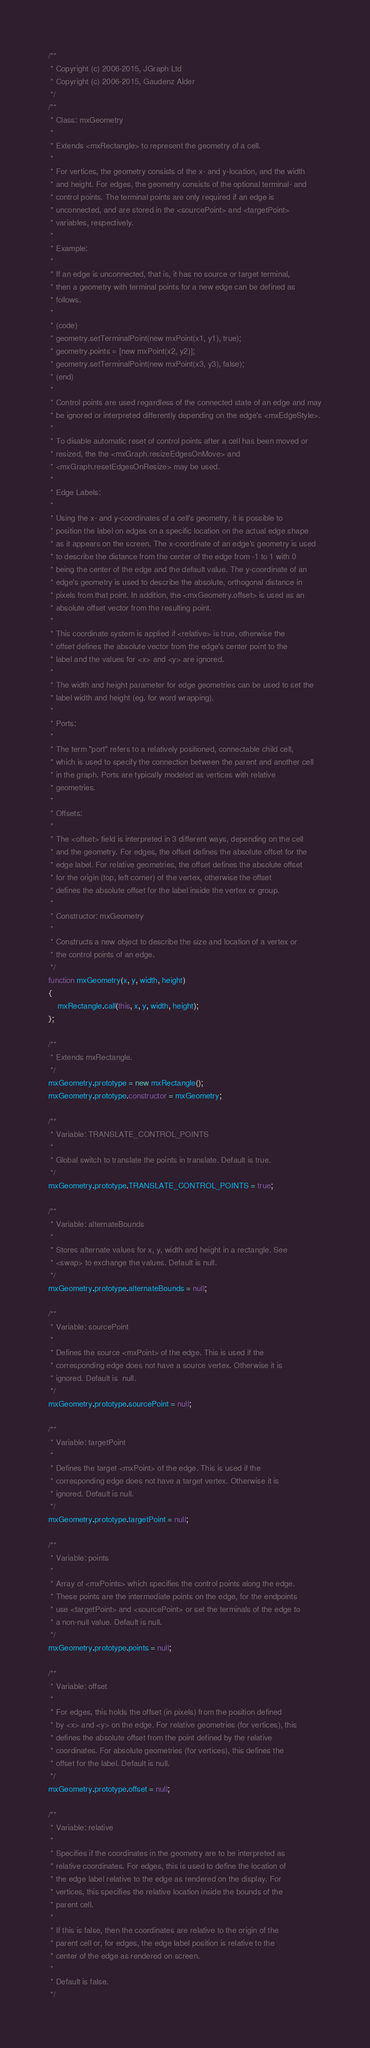Convert code to text. <code><loc_0><loc_0><loc_500><loc_500><_JavaScript_>/**
 * Copyright (c) 2006-2015, JGraph Ltd
 * Copyright (c) 2006-2015, Gaudenz Alder
 */
/**
 * Class: mxGeometry
 *
 * Extends <mxRectangle> to represent the geometry of a cell.
 *
 * For vertices, the geometry consists of the x- and y-location, and the width
 * and height. For edges, the geometry consists of the optional terminal- and
 * control points. The terminal points are only required if an edge is
 * unconnected, and are stored in the <sourcePoint> and <targetPoint>
 * variables, respectively.
 *
 * Example:
 *
 * If an edge is unconnected, that is, it has no source or target terminal,
 * then a geometry with terminal points for a new edge can be defined as
 * follows.
 *
 * (code)
 * geometry.setTerminalPoint(new mxPoint(x1, y1), true);
 * geometry.points = [new mxPoint(x2, y2)];
 * geometry.setTerminalPoint(new mxPoint(x3, y3), false);
 * (end)
 *
 * Control points are used regardless of the connected state of an edge and may
 * be ignored or interpreted differently depending on the edge's <mxEdgeStyle>.
 *
 * To disable automatic reset of control points after a cell has been moved or
 * resized, the the <mxGraph.resizeEdgesOnMove> and
 * <mxGraph.resetEdgesOnResize> may be used.
 *
 * Edge Labels:
 *
 * Using the x- and y-coordinates of a cell's geometry, it is possible to
 * position the label on edges on a specific location on the actual edge shape
 * as it appears on the screen. The x-coordinate of an edge's geometry is used
 * to describe the distance from the center of the edge from -1 to 1 with 0
 * being the center of the edge and the default value. The y-coordinate of an
 * edge's geometry is used to describe the absolute, orthogonal distance in
 * pixels from that point. In addition, the <mxGeometry.offset> is used as an
 * absolute offset vector from the resulting point.
 *
 * This coordinate system is applied if <relative> is true, otherwise the
 * offset defines the absolute vector from the edge's center point to the
 * label and the values for <x> and <y> are ignored.
 *
 * The width and height parameter for edge geometries can be used to set the
 * label width and height (eg. for word wrapping).
 *
 * Ports:
 *
 * The term "port" refers to a relatively positioned, connectable child cell,
 * which is used to specify the connection between the parent and another cell
 * in the graph. Ports are typically modeled as vertices with relative
 * geometries.
 *
 * Offsets:
 *
 * The <offset> field is interpreted in 3 different ways, depending on the cell
 * and the geometry. For edges, the offset defines the absolute offset for the
 * edge label. For relative geometries, the offset defines the absolute offset
 * for the origin (top, left corner) of the vertex, otherwise the offset
 * defines the absolute offset for the label inside the vertex or group.
 *
 * Constructor: mxGeometry
 *
 * Constructs a new object to describe the size and location of a vertex or
 * the control points of an edge.
 */
function mxGeometry(x, y, width, height)
{
	mxRectangle.call(this, x, y, width, height);
};

/**
 * Extends mxRectangle.
 */
mxGeometry.prototype = new mxRectangle();
mxGeometry.prototype.constructor = mxGeometry;

/**
 * Variable: TRANSLATE_CONTROL_POINTS
 *
 * Global switch to translate the points in translate. Default is true.
 */
mxGeometry.prototype.TRANSLATE_CONTROL_POINTS = true;

/**
 * Variable: alternateBounds
 *
 * Stores alternate values for x, y, width and height in a rectangle. See
 * <swap> to exchange the values. Default is null.
 */
mxGeometry.prototype.alternateBounds = null;

/**
 * Variable: sourcePoint
 *
 * Defines the source <mxPoint> of the edge. This is used if the
 * corresponding edge does not have a source vertex. Otherwise it is
 * ignored. Default is  null.
 */
mxGeometry.prototype.sourcePoint = null;

/**
 * Variable: targetPoint
 *
 * Defines the target <mxPoint> of the edge. This is used if the
 * corresponding edge does not have a target vertex. Otherwise it is
 * ignored. Default is null.
 */
mxGeometry.prototype.targetPoint = null;

/**
 * Variable: points
 *
 * Array of <mxPoints> which specifies the control points along the edge.
 * These points are the intermediate points on the edge, for the endpoints
 * use <targetPoint> and <sourcePoint> or set the terminals of the edge to
 * a non-null value. Default is null.
 */
mxGeometry.prototype.points = null;

/**
 * Variable: offset
 *
 * For edges, this holds the offset (in pixels) from the position defined
 * by <x> and <y> on the edge. For relative geometries (for vertices), this
 * defines the absolute offset from the point defined by the relative
 * coordinates. For absolute geometries (for vertices), this defines the
 * offset for the label. Default is null.
 */
mxGeometry.prototype.offset = null;

/**
 * Variable: relative
 *
 * Specifies if the coordinates in the geometry are to be interpreted as
 * relative coordinates. For edges, this is used to define the location of
 * the edge label relative to the edge as rendered on the display. For
 * vertices, this specifies the relative location inside the bounds of the
 * parent cell.
 *
 * If this is false, then the coordinates are relative to the origin of the
 * parent cell or, for edges, the edge label position is relative to the
 * center of the edge as rendered on screen.
 *
 * Default is false.
 */</code> 